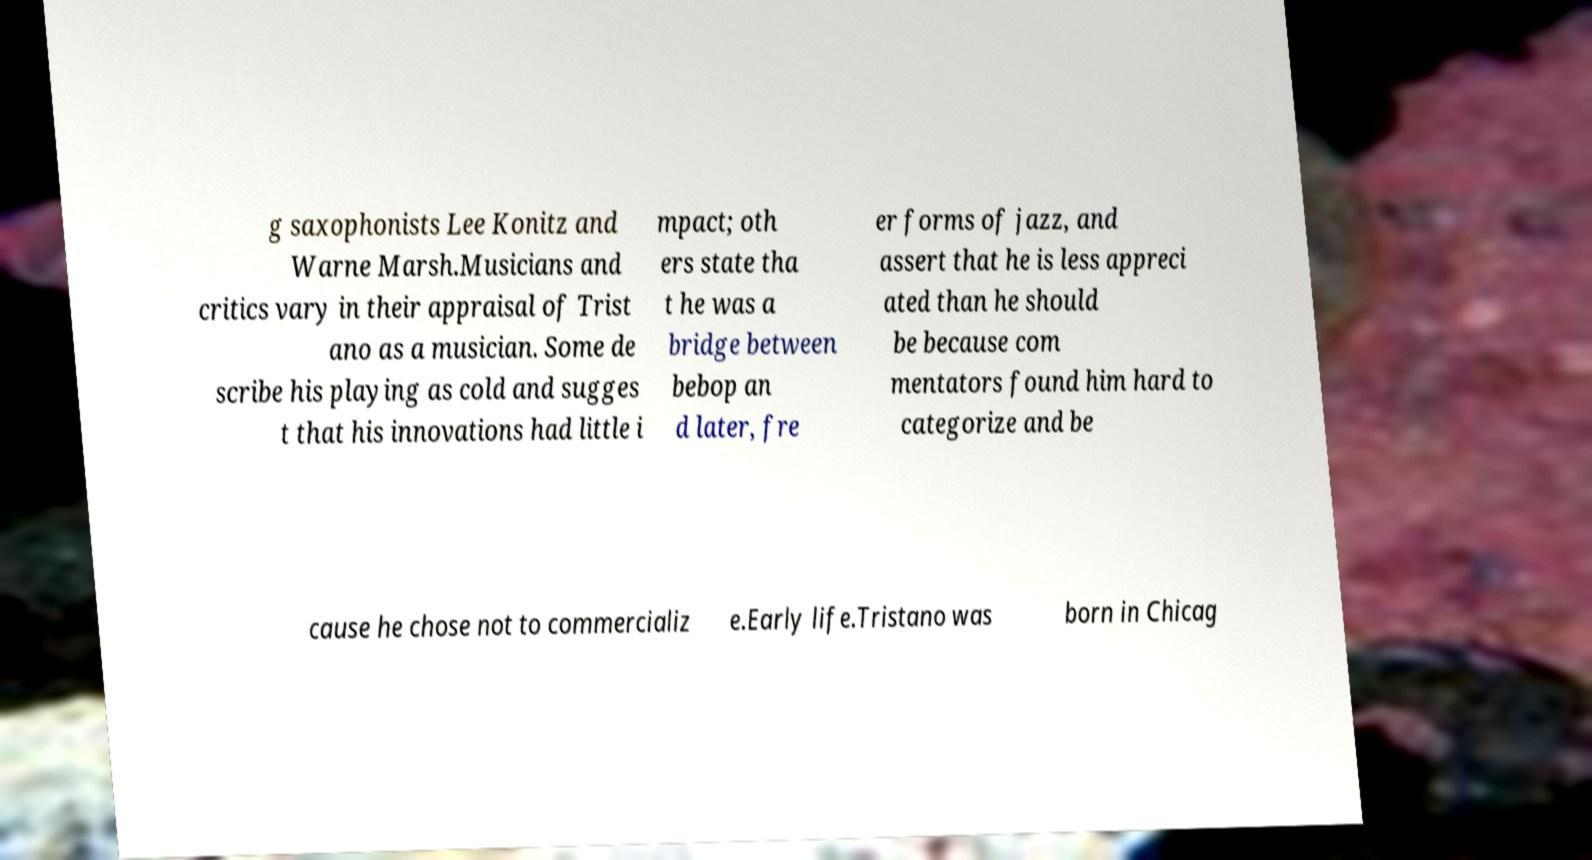Could you assist in decoding the text presented in this image and type it out clearly? g saxophonists Lee Konitz and Warne Marsh.Musicians and critics vary in their appraisal of Trist ano as a musician. Some de scribe his playing as cold and sugges t that his innovations had little i mpact; oth ers state tha t he was a bridge between bebop an d later, fre er forms of jazz, and assert that he is less appreci ated than he should be because com mentators found him hard to categorize and be cause he chose not to commercializ e.Early life.Tristano was born in Chicag 